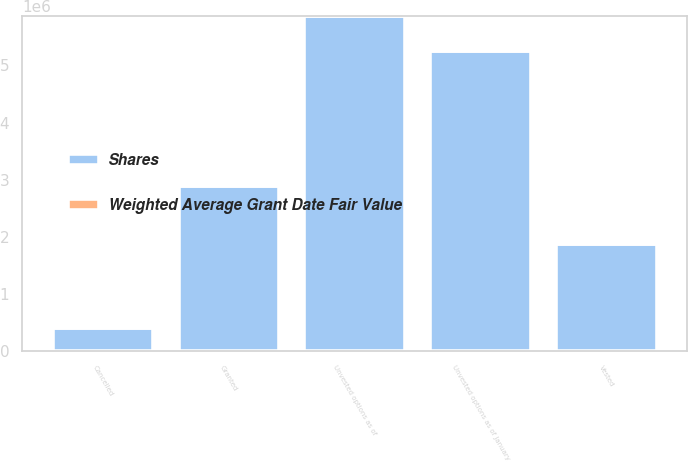Convert chart to OTSL. <chart><loc_0><loc_0><loc_500><loc_500><stacked_bar_chart><ecel><fcel>Unvested options as of January<fcel>Granted<fcel>Vested<fcel>Cancelled<fcel>Unvested options as of<nl><fcel>Shares<fcel>5.25093e+06<fcel>2.88975e+06<fcel>1.86498e+06<fcel>410864<fcel>5.86483e+06<nl><fcel>Weighted Average Grant Date Fair Value<fcel>10.74<fcel>13.33<fcel>10.22<fcel>11.66<fcel>12.12<nl></chart> 